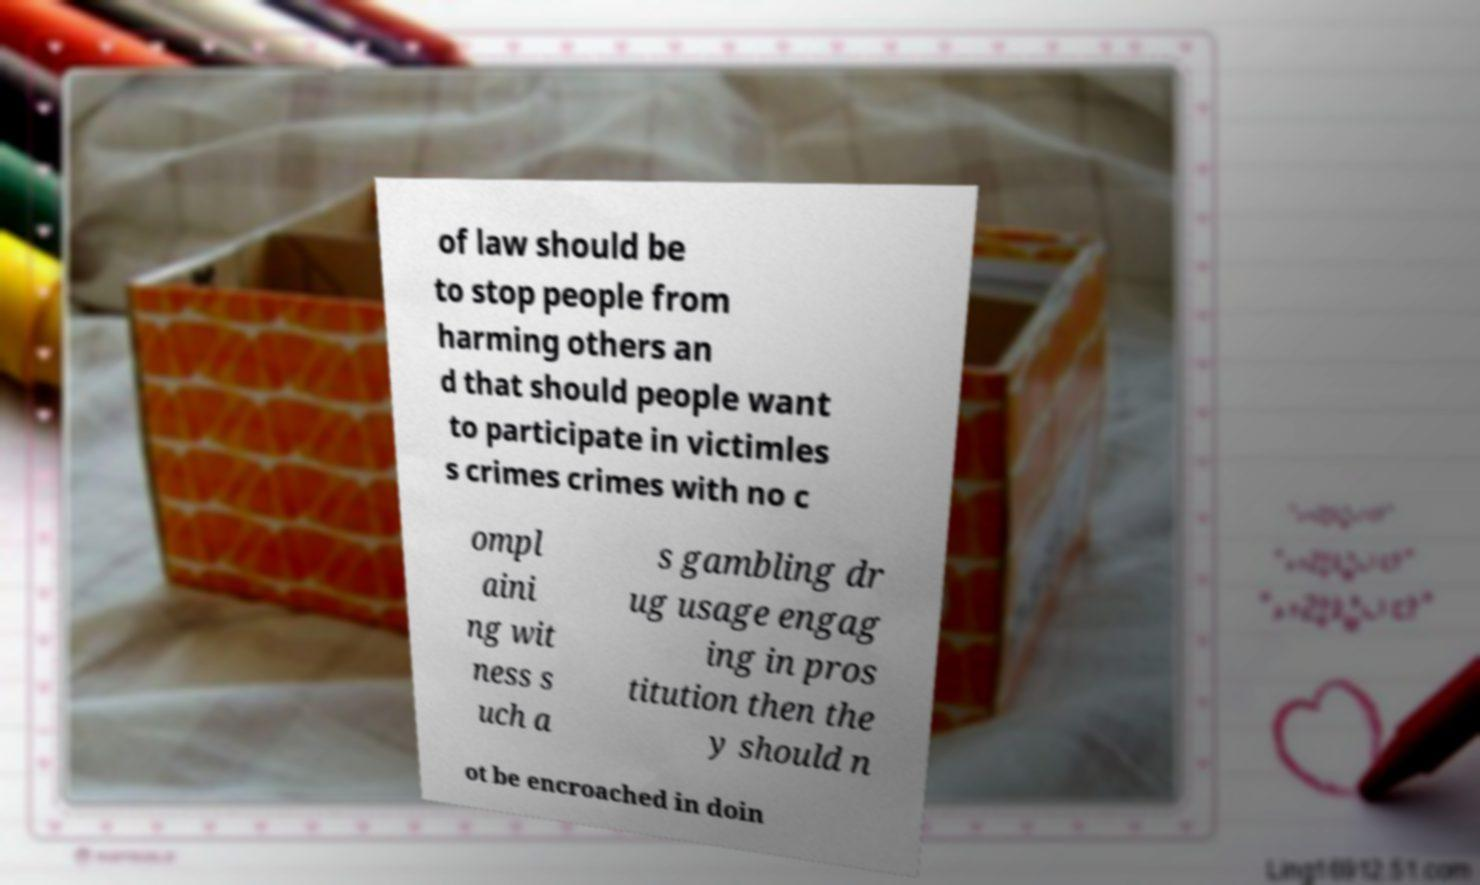What messages or text are displayed in this image? I need them in a readable, typed format. of law should be to stop people from harming others an d that should people want to participate in victimles s crimes crimes with no c ompl aini ng wit ness s uch a s gambling dr ug usage engag ing in pros titution then the y should n ot be encroached in doin 